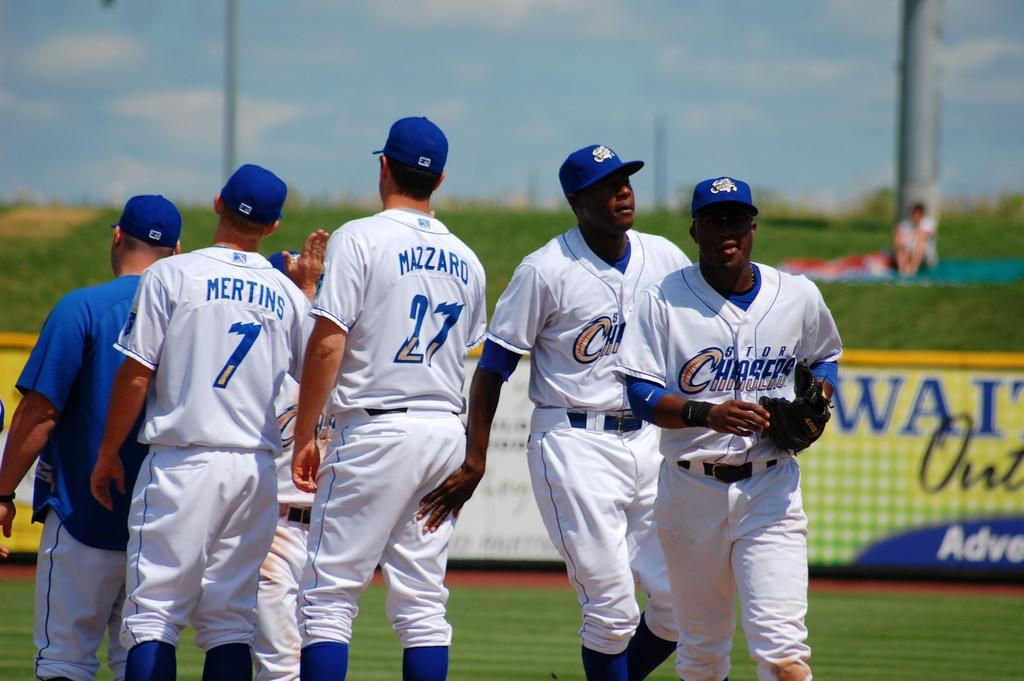<image>
Present a compact description of the photo's key features. A group of baseball player with a blue and white uniform that says Chasers. 